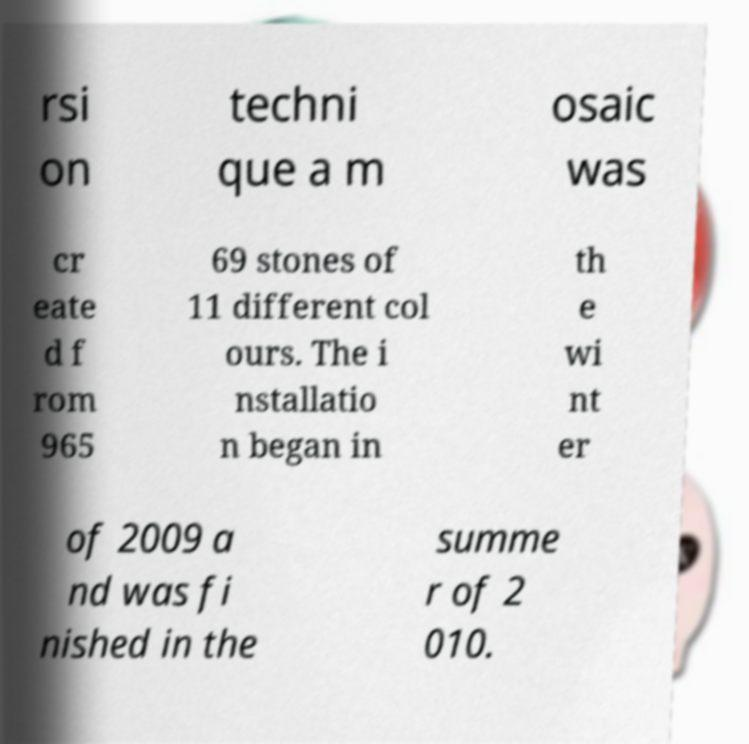Please read and relay the text visible in this image. What does it say? rsi on techni que a m osaic was cr eate d f rom 965 69 stones of 11 different col ours. The i nstallatio n began in th e wi nt er of 2009 a nd was fi nished in the summe r of 2 010. 